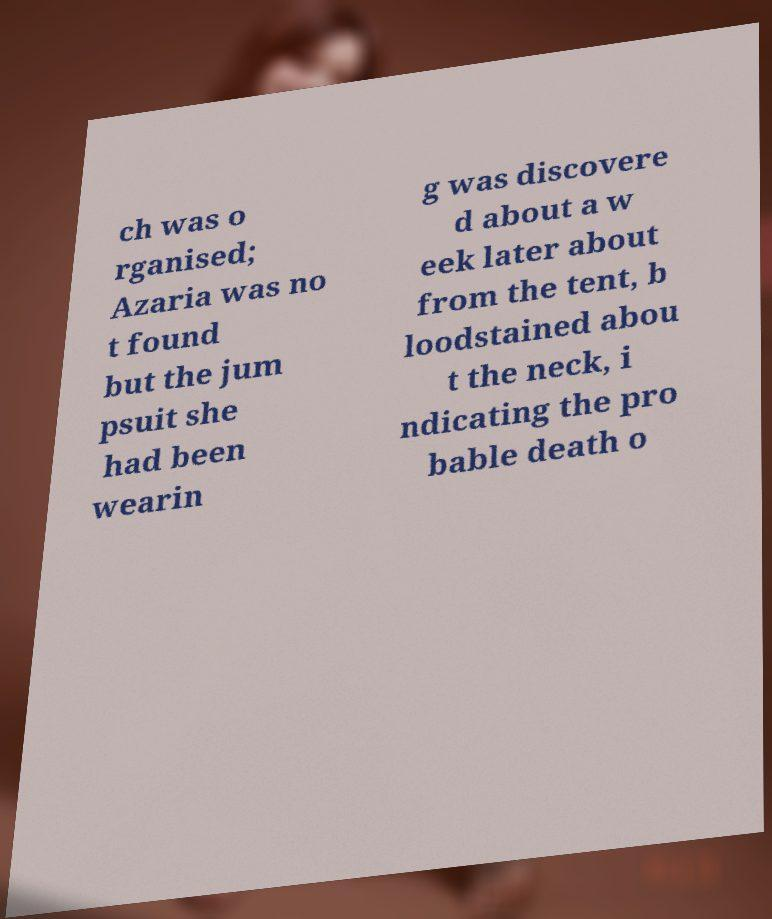There's text embedded in this image that I need extracted. Can you transcribe it verbatim? ch was o rganised; Azaria was no t found but the jum psuit she had been wearin g was discovere d about a w eek later about from the tent, b loodstained abou t the neck, i ndicating the pro bable death o 